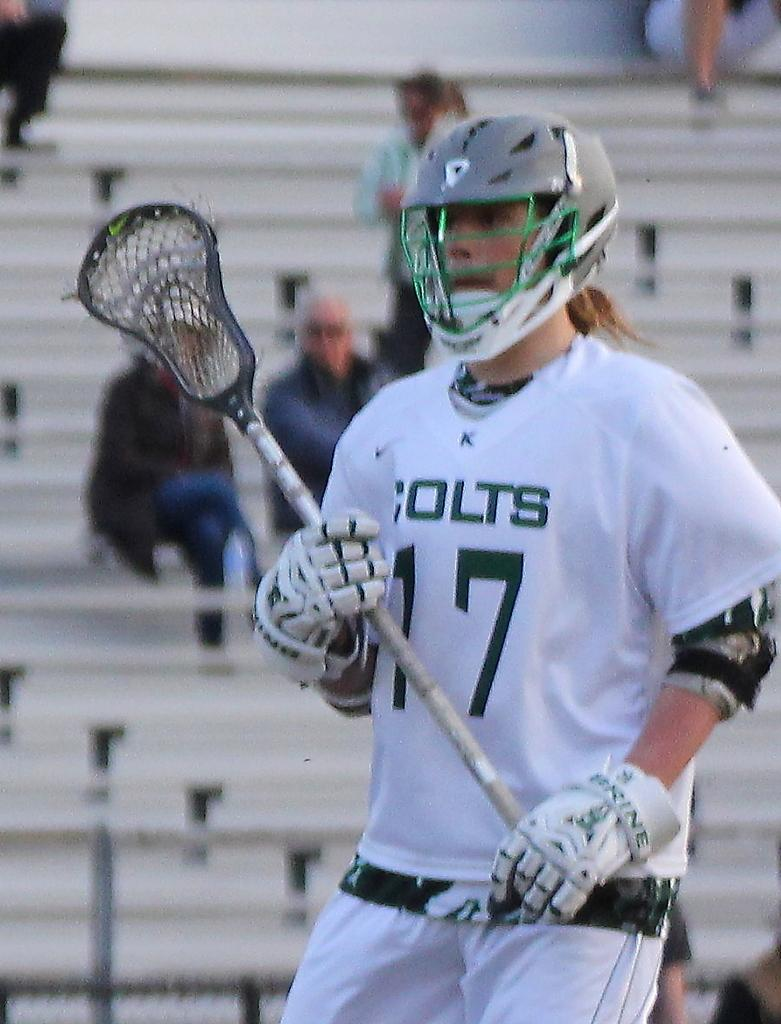What can be seen in the image? There is a person in the image. What is the person wearing? The person is wearing a white dress, a helmet, and gloves. What is the person holding in his hands? The person is holding a stick in his hands. What can be seen in the background of the image? There is a group of audience in the background of the image. What rule does the person's son break in the image? There is no son present in the image, and therefore no rule-breaking can be observed. 